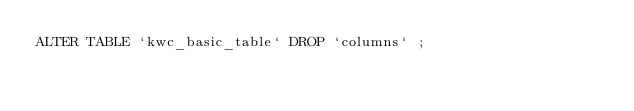<code> <loc_0><loc_0><loc_500><loc_500><_SQL_>ALTER TABLE `kwc_basic_table` DROP `columns` ;
</code> 